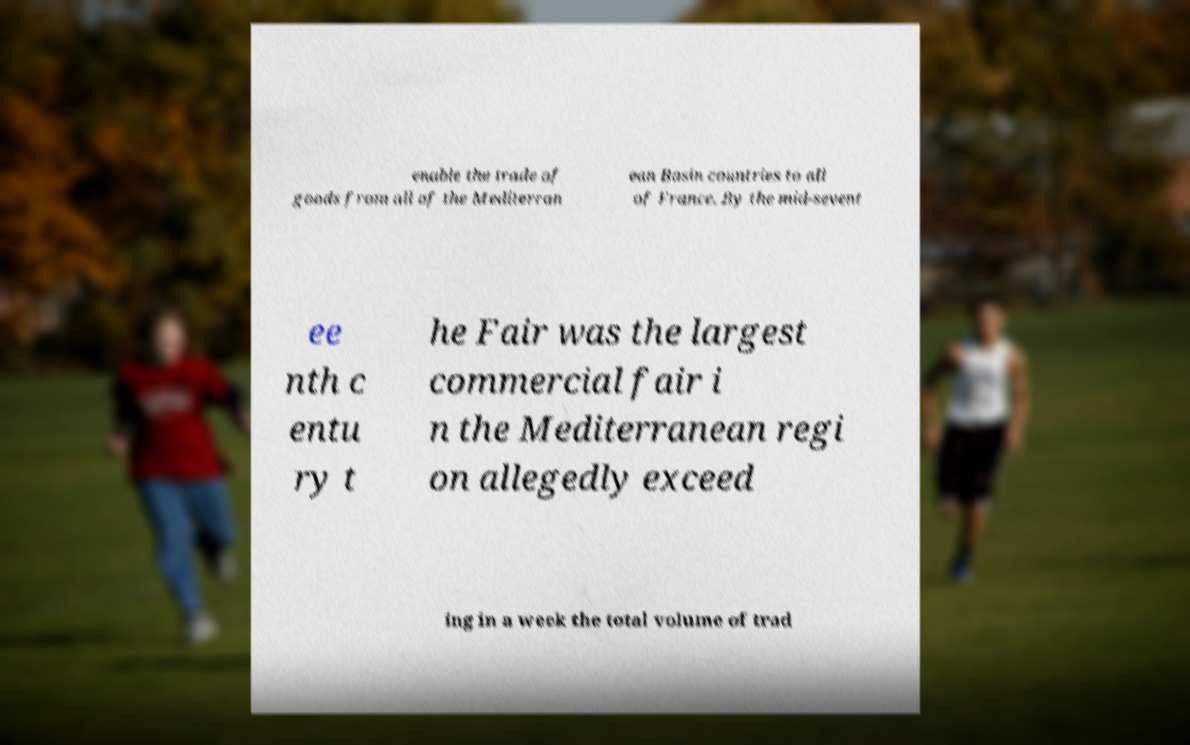Could you extract and type out the text from this image? enable the trade of goods from all of the Mediterran ean Basin countries to all of France. By the mid-sevent ee nth c entu ry t he Fair was the largest commercial fair i n the Mediterranean regi on allegedly exceed ing in a week the total volume of trad 